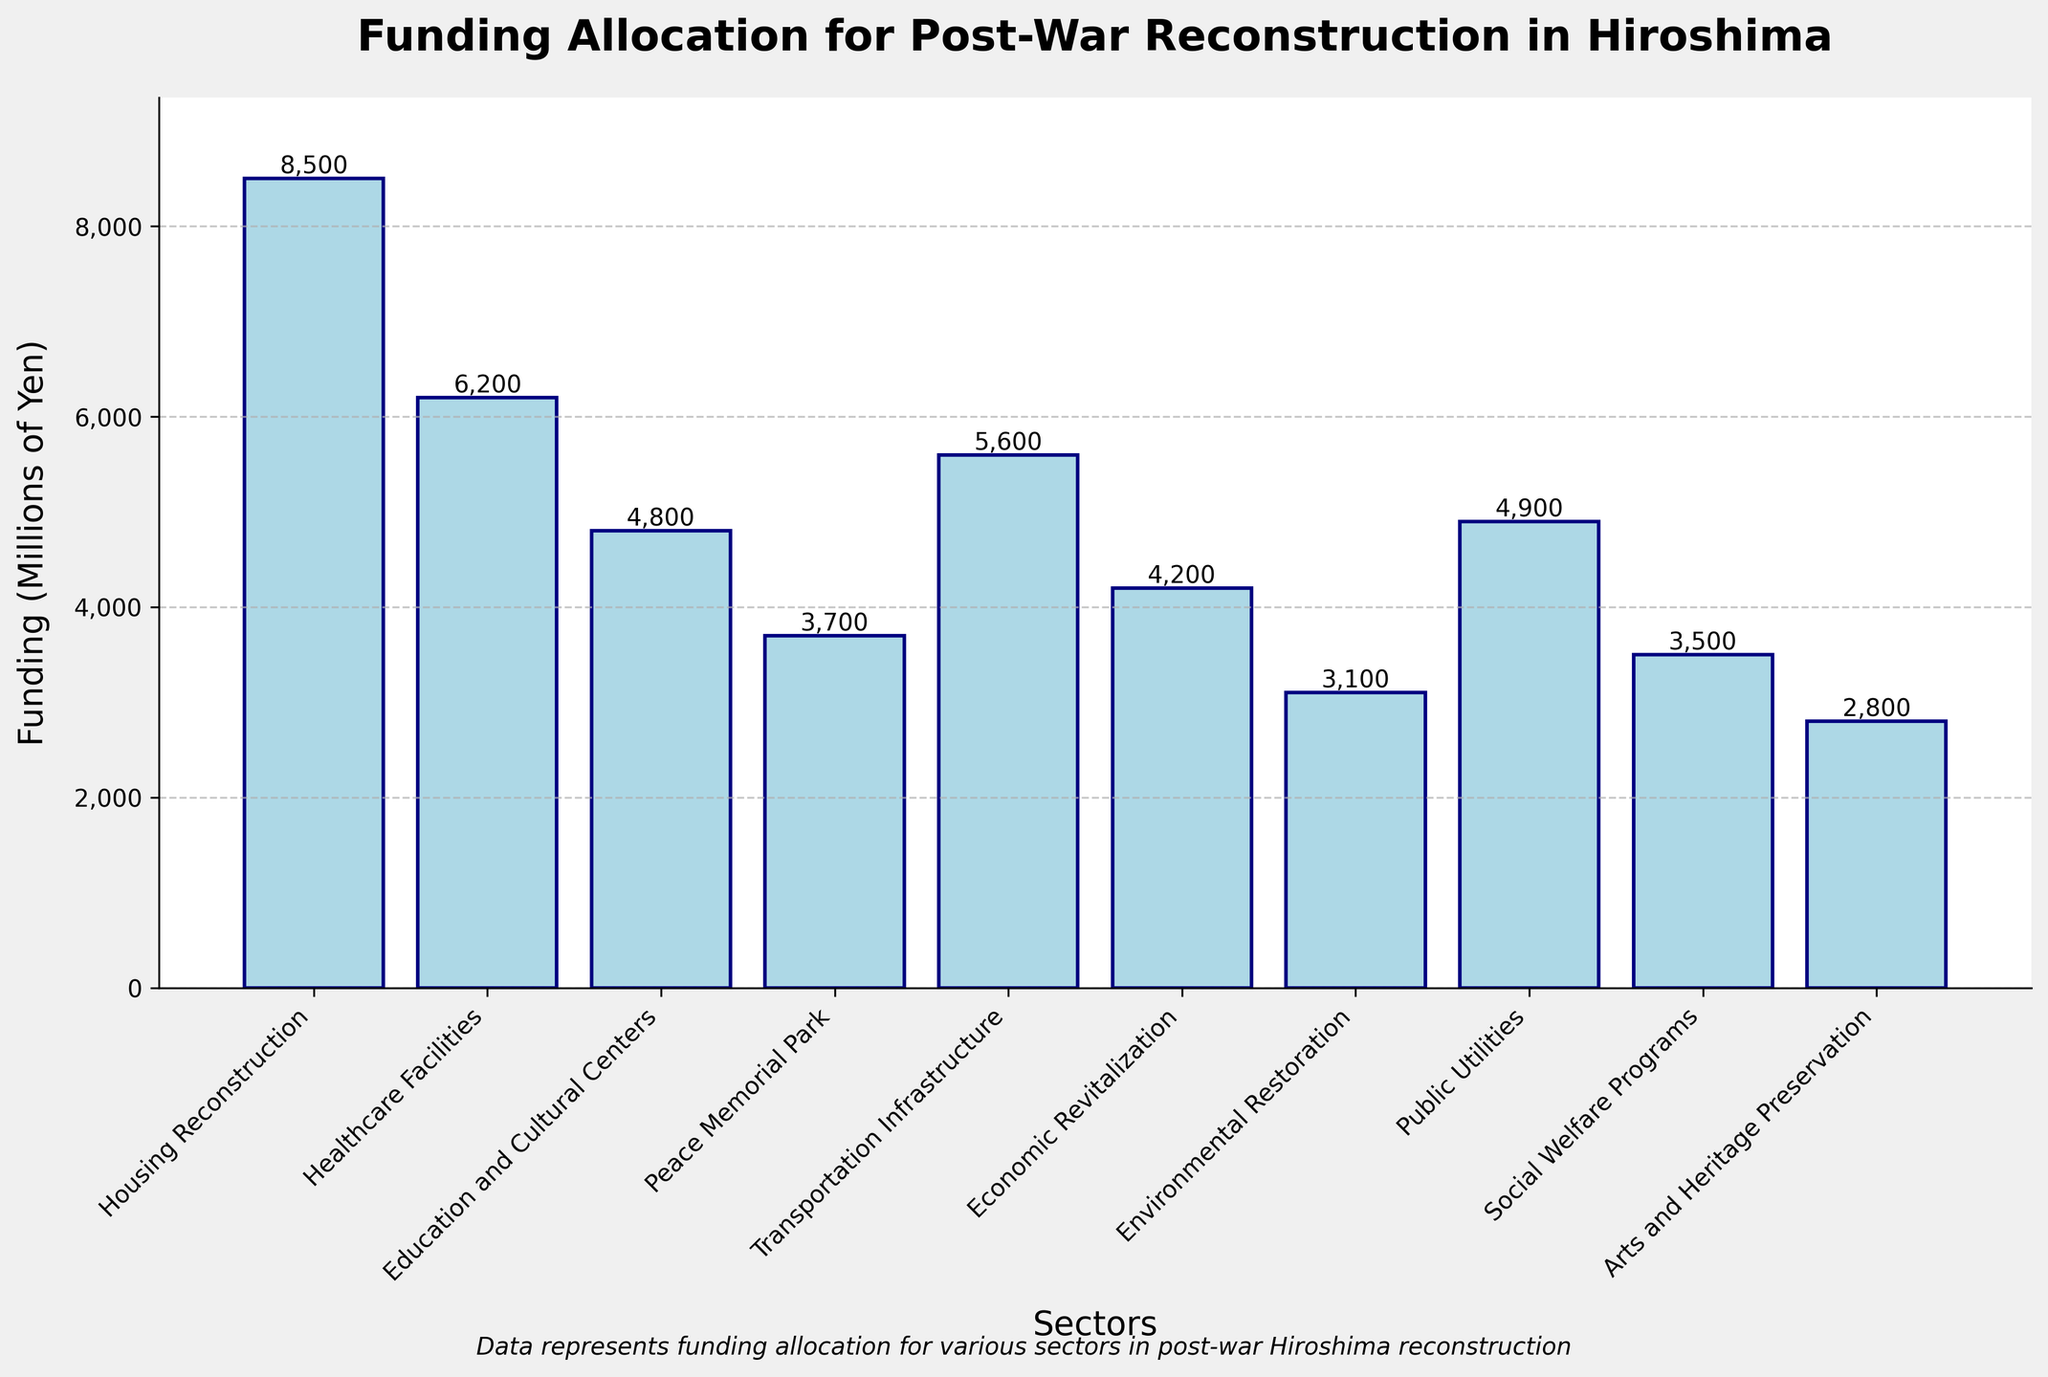Which sector has the highest funding allocation? By looking at the height of each bar, the bar labeled "Housing Reconstruction" is noticeably taller than the others. The numerical label at the top of this bar indicates it has the highest funding allocation at 8,500 million yen.
Answer: Housing Reconstruction Which sector has the least funding allocation? The shortest bar in the bar chart represents "Arts and Heritage Preservation". The numerical label confirms this sector received 2,800 million yen, which is the lowest among all sectors.
Answer: Arts and Heritage Preservation How much more funding does Housing Reconstruction have compared to Healthcare Facilities? The funding for Housing Reconstruction is 8,500 million yen, while for Healthcare Facilities, it is 6,200 million yen. The difference between them is 8,500 - 6,200 = 2,300 million yen.
Answer: 2,300 million yen What is the cumulative funding for Education and Cultural Centers, Peace Memorial Park, and Economic Revitalization? To find the cumulative funding, sum up the individual amounts: 4,800 million yen for Education and Cultural Centers, 3,700 million yen for Peace Memorial Park, and 4,200 million yen for Economic Revitalization. Therefore, 4,800 + 3,700 + 4,200 = 12,700 million yen.
Answer: 12,700 million yen Which sector has a funding allocation closest to 5,000 million yen? By observing the bar heights and their corresponding numerical labels, "Public Utilities" has a funding allocation of 4,900 million yen, which is the closest to 5,000 million yen.
Answer: Public Utilities Rank the top three sectors in terms of funding allocation. By observing the heights of the bars, the top three sectors with the highest funding are: 1. Housing Reconstruction (8,500 million yen), 2. Healthcare Facilities (6,200 million yen), and 3. Transportation Infrastructure (5,600 million yen).
Answer: Housing Reconstruction, Healthcare Facilities, Transportation Infrastructure What is the average funding allocated across all sectors? There are 10 sectors with respective funding: 8,500, 6,200, 4,800, 3,700, 5,600, 4,200, 3,100, 4,900, 3,500, 2,800 million yen. Summing these values: 8,500 + 6,200 + 4,800 + 3,700 + 5,600 + 4,200 + 3,100 + 4,900 + 3,500 + 2,800 = 47,300 million yen. The average funding is 47,300 / 10 = 4,730 million yen.
Answer: 4,730 million yen Are there more sectors with funding above 4,000 million yen or below 4,000 million yen? List the sectors and their funding to count:
- Above 4,000 million yen: Housing Reconstruction, Healthcare Facilities, Education and Cultural Centers, Transportation Infrastructure, Economic Revitalization, Public Utilities (6 sectors)
- Below 4,000 million yen: Peace Memorial Park, Environmental Restoration, Social Welfare Programs, Arts and Heritage Preservation (4 sectors)
There are more sectors with funding above 4,000 million yen (6 sectors) than below (4 sectors).
Answer: Above 4,000 million yen Which sector's funding is closest in value to the funding for Social Welfare Programs? Social Welfare Programs has funding of 3,500 million yen. By comparing, the funding values closest are: 
- Environmental Restoration: 3,100 million yen (difference of 400 million yen)
- Peace Memorial Park: 3,700 million yen (difference of 200 million yen)
Therefore, funding for Peace Memorial Park is the closest to Social Welfare Programs.
Answer: Peace Memorial Park 